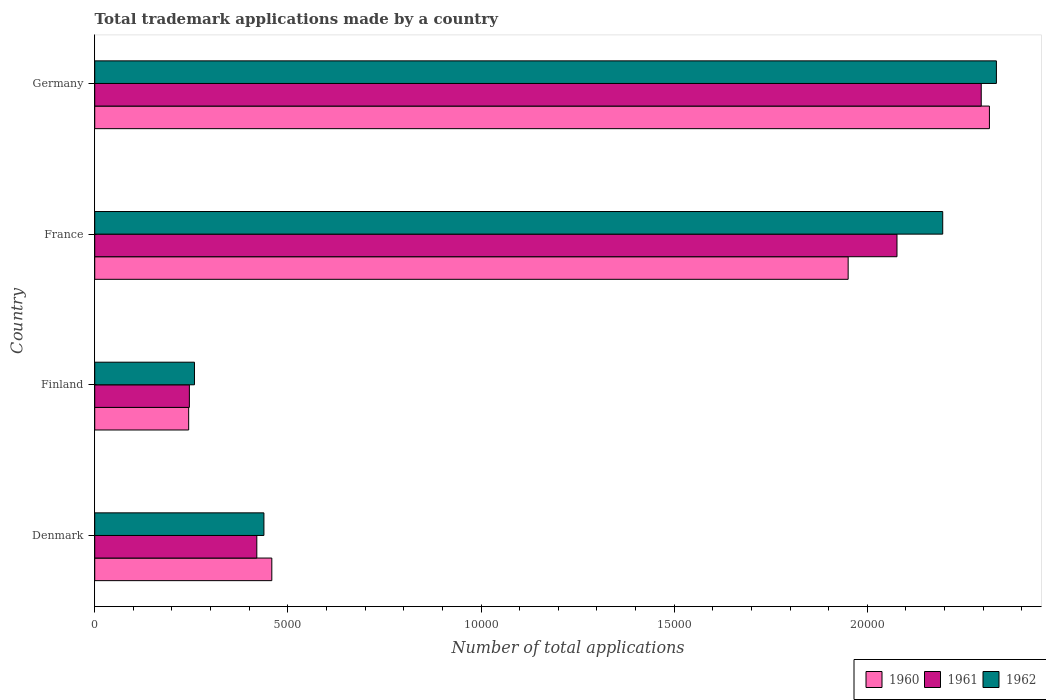How many different coloured bars are there?
Give a very brief answer. 3. How many groups of bars are there?
Make the answer very short. 4. What is the label of the 4th group of bars from the top?
Offer a terse response. Denmark. What is the number of applications made by in 1961 in Finland?
Give a very brief answer. 2450. Across all countries, what is the maximum number of applications made by in 1962?
Your answer should be compact. 2.33e+04. Across all countries, what is the minimum number of applications made by in 1962?
Your response must be concise. 2582. In which country was the number of applications made by in 1961 maximum?
Keep it short and to the point. Germany. In which country was the number of applications made by in 1961 minimum?
Give a very brief answer. Finland. What is the total number of applications made by in 1962 in the graph?
Offer a very short reply. 5.23e+04. What is the difference between the number of applications made by in 1960 in France and that in Germany?
Your response must be concise. -3657. What is the difference between the number of applications made by in 1962 in France and the number of applications made by in 1960 in Finland?
Your answer should be very brief. 1.95e+04. What is the average number of applications made by in 1962 per country?
Make the answer very short. 1.31e+04. What is the difference between the number of applications made by in 1962 and number of applications made by in 1961 in Finland?
Make the answer very short. 132. In how many countries, is the number of applications made by in 1962 greater than 13000 ?
Give a very brief answer. 2. What is the ratio of the number of applications made by in 1961 in France to that in Germany?
Give a very brief answer. 0.9. What is the difference between the highest and the second highest number of applications made by in 1962?
Ensure brevity in your answer.  1390. What is the difference between the highest and the lowest number of applications made by in 1960?
Provide a succinct answer. 2.07e+04. What does the 2nd bar from the top in Denmark represents?
Your response must be concise. 1961. What does the 1st bar from the bottom in Finland represents?
Offer a terse response. 1960. Is it the case that in every country, the sum of the number of applications made by in 1960 and number of applications made by in 1961 is greater than the number of applications made by in 1962?
Give a very brief answer. Yes. What is the difference between two consecutive major ticks on the X-axis?
Keep it short and to the point. 5000. Are the values on the major ticks of X-axis written in scientific E-notation?
Your response must be concise. No. Where does the legend appear in the graph?
Your answer should be very brief. Bottom right. How many legend labels are there?
Your answer should be very brief. 3. What is the title of the graph?
Offer a very short reply. Total trademark applications made by a country. What is the label or title of the X-axis?
Make the answer very short. Number of total applications. What is the Number of total applications in 1960 in Denmark?
Your answer should be compact. 4584. What is the Number of total applications in 1961 in Denmark?
Your response must be concise. 4196. What is the Number of total applications in 1962 in Denmark?
Your answer should be compact. 4380. What is the Number of total applications in 1960 in Finland?
Your answer should be compact. 2432. What is the Number of total applications of 1961 in Finland?
Your response must be concise. 2450. What is the Number of total applications of 1962 in Finland?
Provide a short and direct response. 2582. What is the Number of total applications of 1960 in France?
Your response must be concise. 1.95e+04. What is the Number of total applications of 1961 in France?
Your answer should be very brief. 2.08e+04. What is the Number of total applications of 1962 in France?
Ensure brevity in your answer.  2.20e+04. What is the Number of total applications in 1960 in Germany?
Provide a short and direct response. 2.32e+04. What is the Number of total applications of 1961 in Germany?
Keep it short and to the point. 2.29e+04. What is the Number of total applications of 1962 in Germany?
Provide a succinct answer. 2.33e+04. Across all countries, what is the maximum Number of total applications of 1960?
Provide a short and direct response. 2.32e+04. Across all countries, what is the maximum Number of total applications in 1961?
Provide a short and direct response. 2.29e+04. Across all countries, what is the maximum Number of total applications of 1962?
Keep it short and to the point. 2.33e+04. Across all countries, what is the minimum Number of total applications of 1960?
Your answer should be compact. 2432. Across all countries, what is the minimum Number of total applications in 1961?
Your answer should be very brief. 2450. Across all countries, what is the minimum Number of total applications in 1962?
Your answer should be compact. 2582. What is the total Number of total applications in 1960 in the graph?
Offer a terse response. 4.97e+04. What is the total Number of total applications of 1961 in the graph?
Make the answer very short. 5.04e+04. What is the total Number of total applications in 1962 in the graph?
Ensure brevity in your answer.  5.23e+04. What is the difference between the Number of total applications of 1960 in Denmark and that in Finland?
Provide a succinct answer. 2152. What is the difference between the Number of total applications of 1961 in Denmark and that in Finland?
Keep it short and to the point. 1746. What is the difference between the Number of total applications of 1962 in Denmark and that in Finland?
Keep it short and to the point. 1798. What is the difference between the Number of total applications of 1960 in Denmark and that in France?
Ensure brevity in your answer.  -1.49e+04. What is the difference between the Number of total applications of 1961 in Denmark and that in France?
Your answer should be very brief. -1.66e+04. What is the difference between the Number of total applications of 1962 in Denmark and that in France?
Provide a short and direct response. -1.76e+04. What is the difference between the Number of total applications of 1960 in Denmark and that in Germany?
Ensure brevity in your answer.  -1.86e+04. What is the difference between the Number of total applications of 1961 in Denmark and that in Germany?
Your answer should be compact. -1.88e+04. What is the difference between the Number of total applications in 1962 in Denmark and that in Germany?
Your answer should be very brief. -1.90e+04. What is the difference between the Number of total applications in 1960 in Finland and that in France?
Offer a very short reply. -1.71e+04. What is the difference between the Number of total applications of 1961 in Finland and that in France?
Ensure brevity in your answer.  -1.83e+04. What is the difference between the Number of total applications in 1962 in Finland and that in France?
Your answer should be compact. -1.94e+04. What is the difference between the Number of total applications of 1960 in Finland and that in Germany?
Your answer should be compact. -2.07e+04. What is the difference between the Number of total applications of 1961 in Finland and that in Germany?
Keep it short and to the point. -2.05e+04. What is the difference between the Number of total applications in 1962 in Finland and that in Germany?
Ensure brevity in your answer.  -2.08e+04. What is the difference between the Number of total applications of 1960 in France and that in Germany?
Provide a succinct answer. -3657. What is the difference between the Number of total applications in 1961 in France and that in Germany?
Your response must be concise. -2181. What is the difference between the Number of total applications of 1962 in France and that in Germany?
Offer a very short reply. -1390. What is the difference between the Number of total applications in 1960 in Denmark and the Number of total applications in 1961 in Finland?
Offer a very short reply. 2134. What is the difference between the Number of total applications in 1960 in Denmark and the Number of total applications in 1962 in Finland?
Your answer should be very brief. 2002. What is the difference between the Number of total applications of 1961 in Denmark and the Number of total applications of 1962 in Finland?
Your answer should be compact. 1614. What is the difference between the Number of total applications of 1960 in Denmark and the Number of total applications of 1961 in France?
Your answer should be very brief. -1.62e+04. What is the difference between the Number of total applications in 1960 in Denmark and the Number of total applications in 1962 in France?
Your answer should be compact. -1.74e+04. What is the difference between the Number of total applications of 1961 in Denmark and the Number of total applications of 1962 in France?
Provide a short and direct response. -1.78e+04. What is the difference between the Number of total applications of 1960 in Denmark and the Number of total applications of 1961 in Germany?
Offer a terse response. -1.84e+04. What is the difference between the Number of total applications in 1960 in Denmark and the Number of total applications in 1962 in Germany?
Keep it short and to the point. -1.88e+04. What is the difference between the Number of total applications in 1961 in Denmark and the Number of total applications in 1962 in Germany?
Offer a terse response. -1.91e+04. What is the difference between the Number of total applications of 1960 in Finland and the Number of total applications of 1961 in France?
Your answer should be very brief. -1.83e+04. What is the difference between the Number of total applications in 1960 in Finland and the Number of total applications in 1962 in France?
Your answer should be compact. -1.95e+04. What is the difference between the Number of total applications of 1961 in Finland and the Number of total applications of 1962 in France?
Keep it short and to the point. -1.95e+04. What is the difference between the Number of total applications of 1960 in Finland and the Number of total applications of 1961 in Germany?
Keep it short and to the point. -2.05e+04. What is the difference between the Number of total applications of 1960 in Finland and the Number of total applications of 1962 in Germany?
Offer a very short reply. -2.09e+04. What is the difference between the Number of total applications of 1961 in Finland and the Number of total applications of 1962 in Germany?
Ensure brevity in your answer.  -2.09e+04. What is the difference between the Number of total applications in 1960 in France and the Number of total applications in 1961 in Germany?
Provide a succinct answer. -3445. What is the difference between the Number of total applications of 1960 in France and the Number of total applications of 1962 in Germany?
Ensure brevity in your answer.  -3838. What is the difference between the Number of total applications in 1961 in France and the Number of total applications in 1962 in Germany?
Your response must be concise. -2574. What is the average Number of total applications of 1960 per country?
Give a very brief answer. 1.24e+04. What is the average Number of total applications of 1961 per country?
Keep it short and to the point. 1.26e+04. What is the average Number of total applications in 1962 per country?
Make the answer very short. 1.31e+04. What is the difference between the Number of total applications in 1960 and Number of total applications in 1961 in Denmark?
Offer a terse response. 388. What is the difference between the Number of total applications of 1960 and Number of total applications of 1962 in Denmark?
Your answer should be very brief. 204. What is the difference between the Number of total applications of 1961 and Number of total applications of 1962 in Denmark?
Offer a terse response. -184. What is the difference between the Number of total applications of 1960 and Number of total applications of 1961 in Finland?
Give a very brief answer. -18. What is the difference between the Number of total applications of 1960 and Number of total applications of 1962 in Finland?
Offer a very short reply. -150. What is the difference between the Number of total applications of 1961 and Number of total applications of 1962 in Finland?
Your response must be concise. -132. What is the difference between the Number of total applications in 1960 and Number of total applications in 1961 in France?
Offer a very short reply. -1264. What is the difference between the Number of total applications of 1960 and Number of total applications of 1962 in France?
Your answer should be very brief. -2448. What is the difference between the Number of total applications in 1961 and Number of total applications in 1962 in France?
Your answer should be very brief. -1184. What is the difference between the Number of total applications in 1960 and Number of total applications in 1961 in Germany?
Your answer should be very brief. 212. What is the difference between the Number of total applications of 1960 and Number of total applications of 1962 in Germany?
Keep it short and to the point. -181. What is the difference between the Number of total applications of 1961 and Number of total applications of 1962 in Germany?
Make the answer very short. -393. What is the ratio of the Number of total applications in 1960 in Denmark to that in Finland?
Offer a terse response. 1.88. What is the ratio of the Number of total applications of 1961 in Denmark to that in Finland?
Ensure brevity in your answer.  1.71. What is the ratio of the Number of total applications in 1962 in Denmark to that in Finland?
Offer a terse response. 1.7. What is the ratio of the Number of total applications in 1960 in Denmark to that in France?
Keep it short and to the point. 0.23. What is the ratio of the Number of total applications of 1961 in Denmark to that in France?
Ensure brevity in your answer.  0.2. What is the ratio of the Number of total applications in 1962 in Denmark to that in France?
Keep it short and to the point. 0.2. What is the ratio of the Number of total applications in 1960 in Denmark to that in Germany?
Your answer should be very brief. 0.2. What is the ratio of the Number of total applications of 1961 in Denmark to that in Germany?
Your response must be concise. 0.18. What is the ratio of the Number of total applications of 1962 in Denmark to that in Germany?
Offer a terse response. 0.19. What is the ratio of the Number of total applications of 1960 in Finland to that in France?
Give a very brief answer. 0.12. What is the ratio of the Number of total applications in 1961 in Finland to that in France?
Make the answer very short. 0.12. What is the ratio of the Number of total applications in 1962 in Finland to that in France?
Your answer should be compact. 0.12. What is the ratio of the Number of total applications in 1960 in Finland to that in Germany?
Offer a terse response. 0.1. What is the ratio of the Number of total applications in 1961 in Finland to that in Germany?
Make the answer very short. 0.11. What is the ratio of the Number of total applications in 1962 in Finland to that in Germany?
Your response must be concise. 0.11. What is the ratio of the Number of total applications in 1960 in France to that in Germany?
Offer a very short reply. 0.84. What is the ratio of the Number of total applications in 1961 in France to that in Germany?
Your answer should be compact. 0.91. What is the ratio of the Number of total applications in 1962 in France to that in Germany?
Ensure brevity in your answer.  0.94. What is the difference between the highest and the second highest Number of total applications in 1960?
Your response must be concise. 3657. What is the difference between the highest and the second highest Number of total applications in 1961?
Your answer should be very brief. 2181. What is the difference between the highest and the second highest Number of total applications in 1962?
Provide a short and direct response. 1390. What is the difference between the highest and the lowest Number of total applications in 1960?
Your response must be concise. 2.07e+04. What is the difference between the highest and the lowest Number of total applications of 1961?
Make the answer very short. 2.05e+04. What is the difference between the highest and the lowest Number of total applications in 1962?
Offer a terse response. 2.08e+04. 